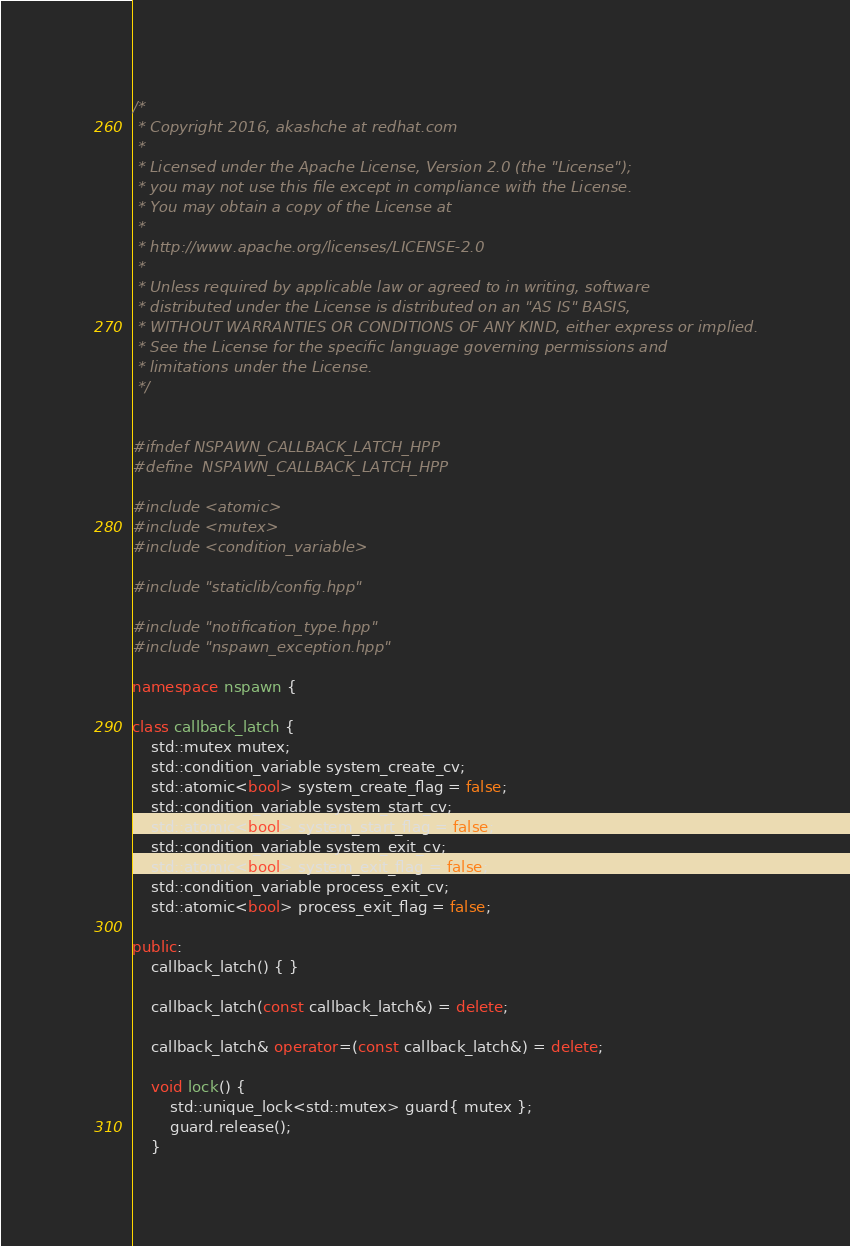<code> <loc_0><loc_0><loc_500><loc_500><_C++_>/*
 * Copyright 2016, akashche at redhat.com
 *
 * Licensed under the Apache License, Version 2.0 (the "License");
 * you may not use this file except in compliance with the License.
 * You may obtain a copy of the License at
 *
 * http://www.apache.org/licenses/LICENSE-2.0
 *
 * Unless required by applicable law or agreed to in writing, software
 * distributed under the License is distributed on an "AS IS" BASIS,
 * WITHOUT WARRANTIES OR CONDITIONS OF ANY KIND, either express or implied.
 * See the License for the specific language governing permissions and
 * limitations under the License.
 */


#ifndef NSPAWN_CALLBACK_LATCH_HPP
#define	NSPAWN_CALLBACK_LATCH_HPP

#include <atomic>
#include <mutex>
#include <condition_variable>

#include "staticlib/config.hpp"

#include "notification_type.hpp"
#include "nspawn_exception.hpp"

namespace nspawn {

class callback_latch {
    std::mutex mutex;
    std::condition_variable system_create_cv;
    std::atomic<bool> system_create_flag = false;
    std::condition_variable system_start_cv;
    std::atomic<bool> system_start_flag = false;
    std::condition_variable system_exit_cv;
    std::atomic<bool> system_exit_flag = false;
    std::condition_variable process_exit_cv;
    std::atomic<bool> process_exit_flag = false;

public:
    callback_latch() { }

    callback_latch(const callback_latch&) = delete;

    callback_latch& operator=(const callback_latch&) = delete;

    void lock() {
        std::unique_lock<std::mutex> guard{ mutex };
        guard.release();
    }
</code> 